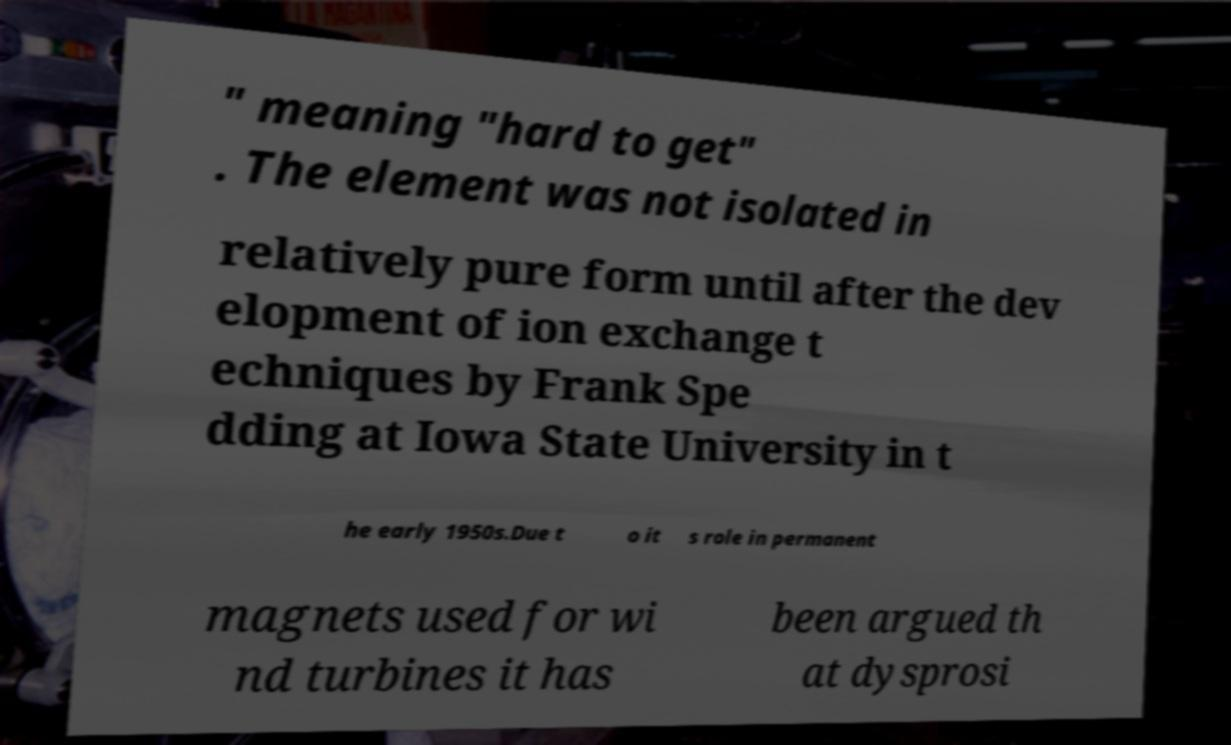Can you accurately transcribe the text from the provided image for me? " meaning "hard to get" . The element was not isolated in relatively pure form until after the dev elopment of ion exchange t echniques by Frank Spe dding at Iowa State University in t he early 1950s.Due t o it s role in permanent magnets used for wi nd turbines it has been argued th at dysprosi 